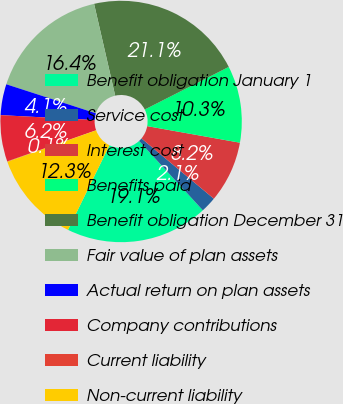Convert chart to OTSL. <chart><loc_0><loc_0><loc_500><loc_500><pie_chart><fcel>Benefit obligation January 1<fcel>Service cost<fcel>Interest cost<fcel>Benefits paid<fcel>Benefit obligation December 31<fcel>Fair value of plan assets<fcel>Actual return on plan assets<fcel>Company contributions<fcel>Current liability<fcel>Non-current liability<nl><fcel>19.09%<fcel>2.11%<fcel>8.24%<fcel>10.28%<fcel>21.13%<fcel>16.42%<fcel>4.15%<fcel>6.2%<fcel>0.06%<fcel>12.33%<nl></chart> 